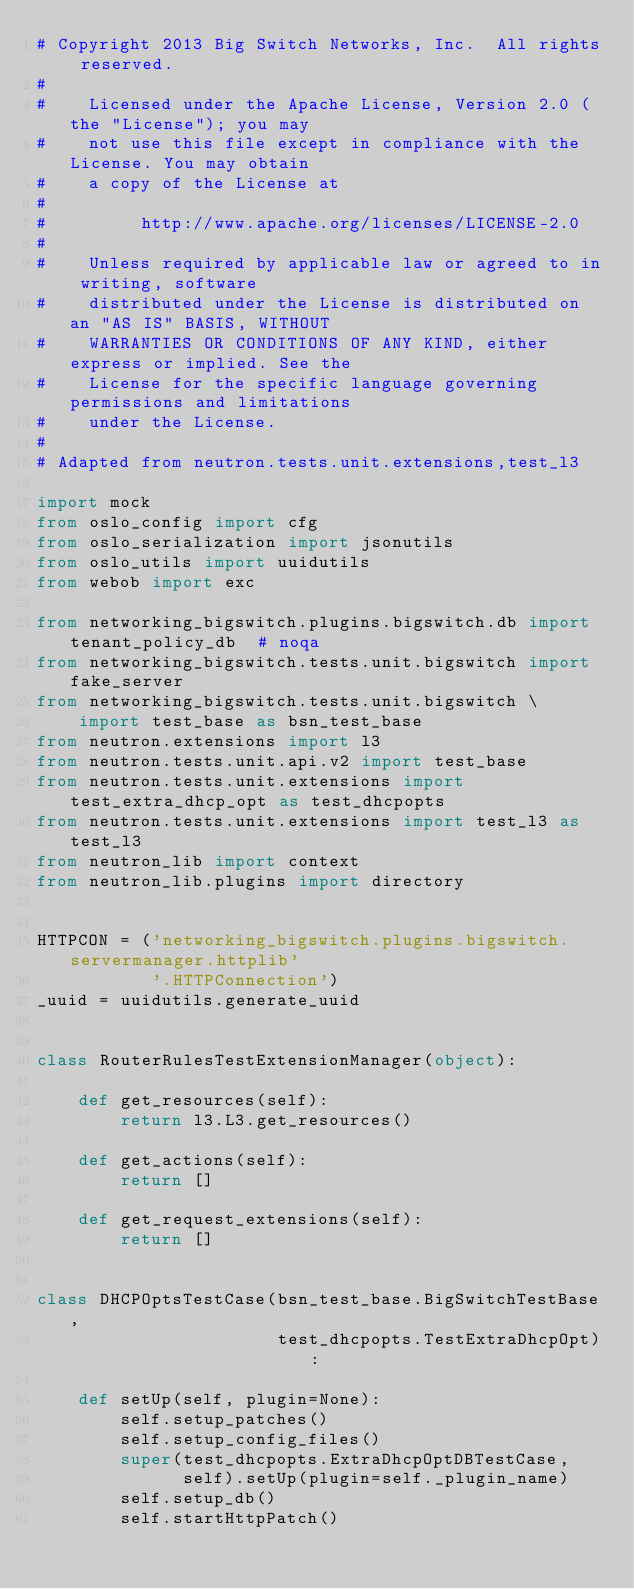Convert code to text. <code><loc_0><loc_0><loc_500><loc_500><_Python_># Copyright 2013 Big Switch Networks, Inc.  All rights reserved.
#
#    Licensed under the Apache License, Version 2.0 (the "License"); you may
#    not use this file except in compliance with the License. You may obtain
#    a copy of the License at
#
#         http://www.apache.org/licenses/LICENSE-2.0
#
#    Unless required by applicable law or agreed to in writing, software
#    distributed under the License is distributed on an "AS IS" BASIS, WITHOUT
#    WARRANTIES OR CONDITIONS OF ANY KIND, either express or implied. See the
#    License for the specific language governing permissions and limitations
#    under the License.
#
# Adapted from neutron.tests.unit.extensions,test_l3

import mock
from oslo_config import cfg
from oslo_serialization import jsonutils
from oslo_utils import uuidutils
from webob import exc

from networking_bigswitch.plugins.bigswitch.db import tenant_policy_db  # noqa
from networking_bigswitch.tests.unit.bigswitch import fake_server
from networking_bigswitch.tests.unit.bigswitch \
    import test_base as bsn_test_base
from neutron.extensions import l3
from neutron.tests.unit.api.v2 import test_base
from neutron.tests.unit.extensions import test_extra_dhcp_opt as test_dhcpopts
from neutron.tests.unit.extensions import test_l3 as test_l3
from neutron_lib import context
from neutron_lib.plugins import directory


HTTPCON = ('networking_bigswitch.plugins.bigswitch.servermanager.httplib'
           '.HTTPConnection')
_uuid = uuidutils.generate_uuid


class RouterRulesTestExtensionManager(object):

    def get_resources(self):
        return l3.L3.get_resources()

    def get_actions(self):
        return []

    def get_request_extensions(self):
        return []


class DHCPOptsTestCase(bsn_test_base.BigSwitchTestBase,
                       test_dhcpopts.TestExtraDhcpOpt):

    def setUp(self, plugin=None):
        self.setup_patches()
        self.setup_config_files()
        super(test_dhcpopts.ExtraDhcpOptDBTestCase,
              self).setUp(plugin=self._plugin_name)
        self.setup_db()
        self.startHttpPatch()

</code> 